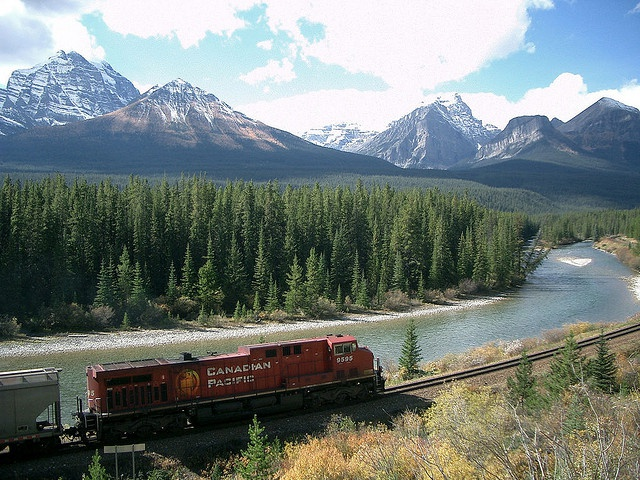Describe the objects in this image and their specific colors. I can see a train in white, black, maroon, gray, and darkgray tones in this image. 